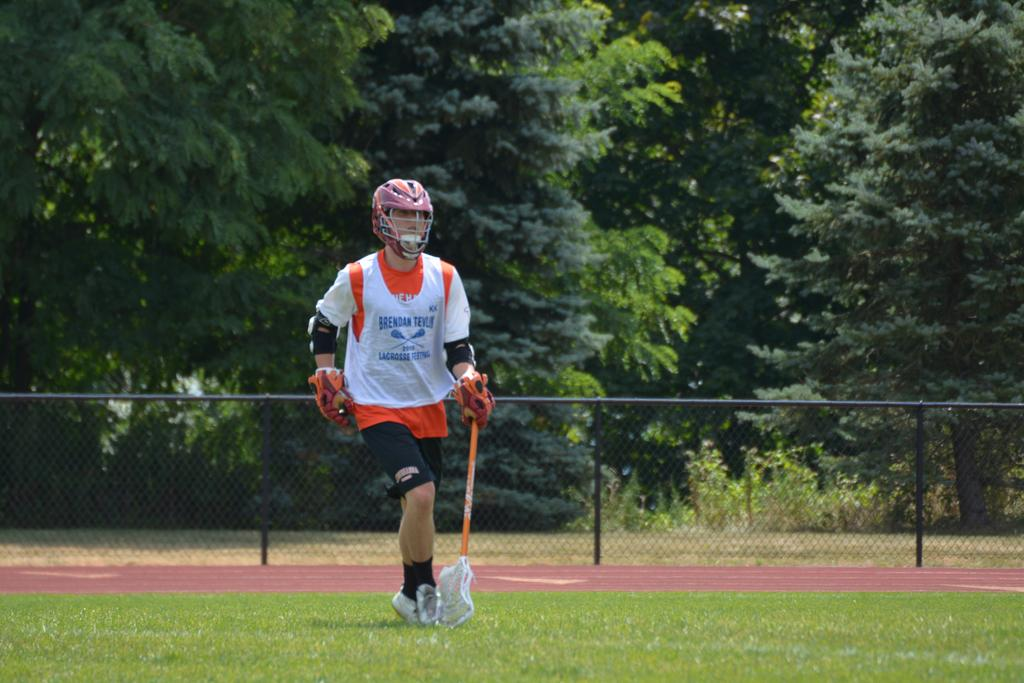<image>
Summarize the visual content of the image. A lacrosse player wearing a Brendan Lacrosse jersey. 